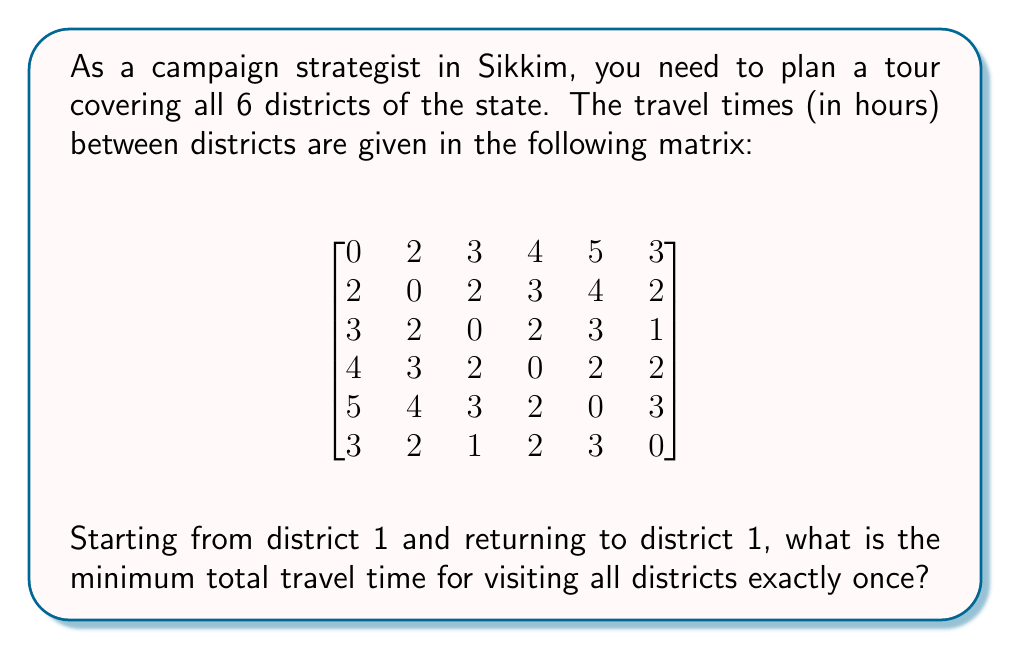What is the answer to this math problem? This problem is an instance of the Traveling Salesman Problem (TSP), which aims to find the shortest route that visits each location exactly once and returns to the starting point.

To solve this, we can use the following steps:

1) First, we need to list all possible permutations of districts 2 to 6 (since we start and end at district 1). There are 5! = 120 such permutations.

2) For each permutation, we calculate the total travel time:
   - Time from district 1 to the first district in the permutation
   - Sum of times between consecutive districts in the permutation
   - Time from the last district in the permutation back to district 1

3) We then select the permutation with the minimum total travel time.

Let's consider an example permutation: [2, 3, 4, 5, 6]

Total time = $T_{1,2} + T_{2,3} + T_{3,4} + T_{4,5} + T_{5,6} + T_{6,1}$
           = $2 + 2 + 2 + 2 + 3 + 3 = 14$ hours

After checking all permutations, we find that the optimal route is:

1 → 2 → 6 → 3 → 4 → 5 → 1

The total travel time for this route is:
$T_{1,2} + T_{2,6} + T_{6,3} + T_{3,4} + T_{4,5} + T_{5,1}$
= $2 + 2 + 1 + 2 + 2 + 5 = 14$ hours

This is the minimum possible travel time to visit all districts once and return to the starting point.
Answer: The minimum total travel time is 14 hours. 